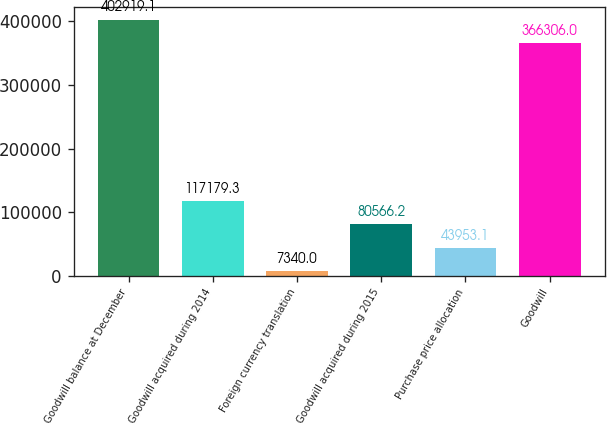Convert chart. <chart><loc_0><loc_0><loc_500><loc_500><bar_chart><fcel>Goodwill balance at December<fcel>Goodwill acquired during 2014<fcel>Foreign currency translation<fcel>Goodwill acquired during 2015<fcel>Purchase price allocation<fcel>Goodwill<nl><fcel>402919<fcel>117179<fcel>7340<fcel>80566.2<fcel>43953.1<fcel>366306<nl></chart> 